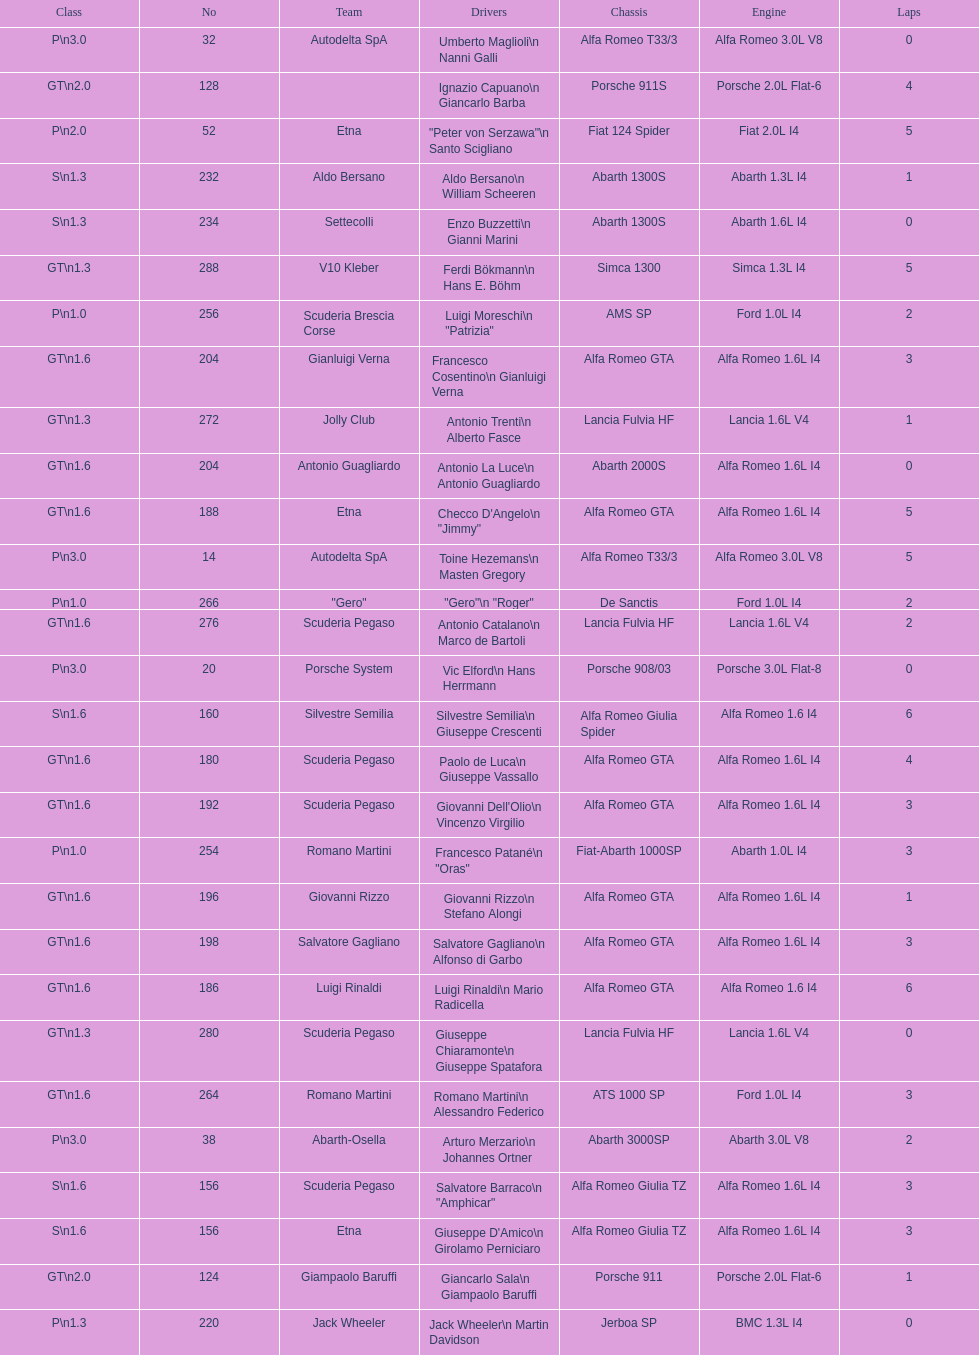Name the only american who did not finish the race. Masten Gregory. 